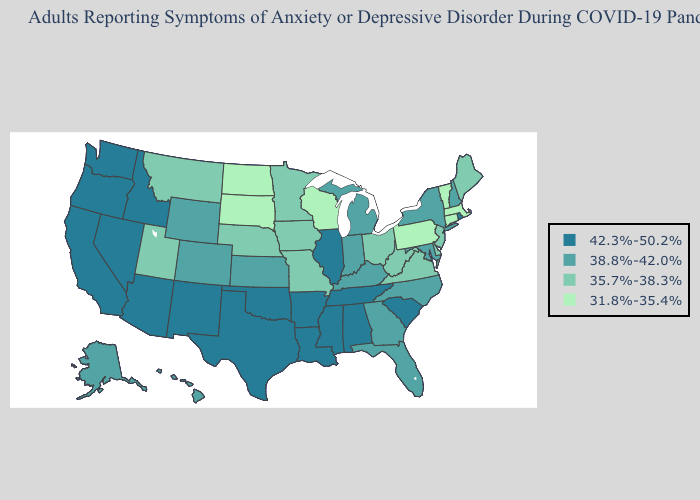Does the map have missing data?
Write a very short answer. No. Name the states that have a value in the range 31.8%-35.4%?
Be succinct. Connecticut, Massachusetts, North Dakota, Pennsylvania, South Dakota, Vermont, Wisconsin. Among the states that border Montana , which have the highest value?
Write a very short answer. Idaho. Does the first symbol in the legend represent the smallest category?
Quick response, please. No. What is the highest value in states that border California?
Keep it brief. 42.3%-50.2%. What is the highest value in the Northeast ?
Short answer required. 42.3%-50.2%. Does Massachusetts have the highest value in the Northeast?
Keep it brief. No. Does the map have missing data?
Short answer required. No. Which states have the lowest value in the Northeast?
Concise answer only. Connecticut, Massachusetts, Pennsylvania, Vermont. Does Rhode Island have the highest value in the Northeast?
Give a very brief answer. Yes. Does Louisiana have the lowest value in the USA?
Give a very brief answer. No. What is the value of New Hampshire?
Keep it brief. 38.8%-42.0%. Name the states that have a value in the range 42.3%-50.2%?
Concise answer only. Alabama, Arizona, Arkansas, California, Idaho, Illinois, Louisiana, Mississippi, Nevada, New Mexico, Oklahoma, Oregon, Rhode Island, South Carolina, Tennessee, Texas, Washington. Does West Virginia have a lower value than Nebraska?
Write a very short answer. No. Name the states that have a value in the range 31.8%-35.4%?
Be succinct. Connecticut, Massachusetts, North Dakota, Pennsylvania, South Dakota, Vermont, Wisconsin. 